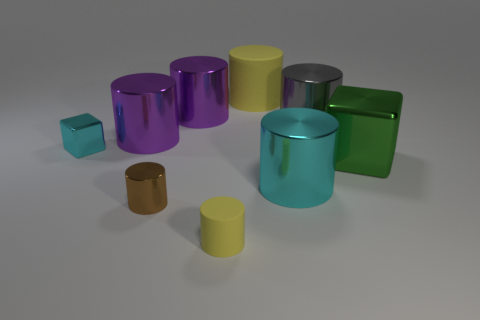There is a big rubber object that is the same color as the tiny matte object; what is its shape?
Ensure brevity in your answer.  Cylinder. The cyan metal thing that is on the left side of the big yellow matte thing has what shape?
Give a very brief answer. Cube. Is there a green shiny block of the same size as the gray object?
Provide a succinct answer. Yes. What material is the gray thing that is the same size as the green shiny block?
Make the answer very short. Metal. What is the size of the cube left of the large cyan shiny object?
Keep it short and to the point. Small. How big is the brown metallic cylinder?
Keep it short and to the point. Small. There is a cyan cylinder; is it the same size as the yellow matte object behind the large cyan object?
Your answer should be compact. Yes. What is the color of the rubber thing in front of the green object right of the gray object?
Ensure brevity in your answer.  Yellow. Is the number of metal objects that are in front of the small cyan metallic block the same as the number of big things that are in front of the brown object?
Your response must be concise. No. Is the material of the yellow thing behind the small cyan shiny thing the same as the brown cylinder?
Offer a terse response. No. 